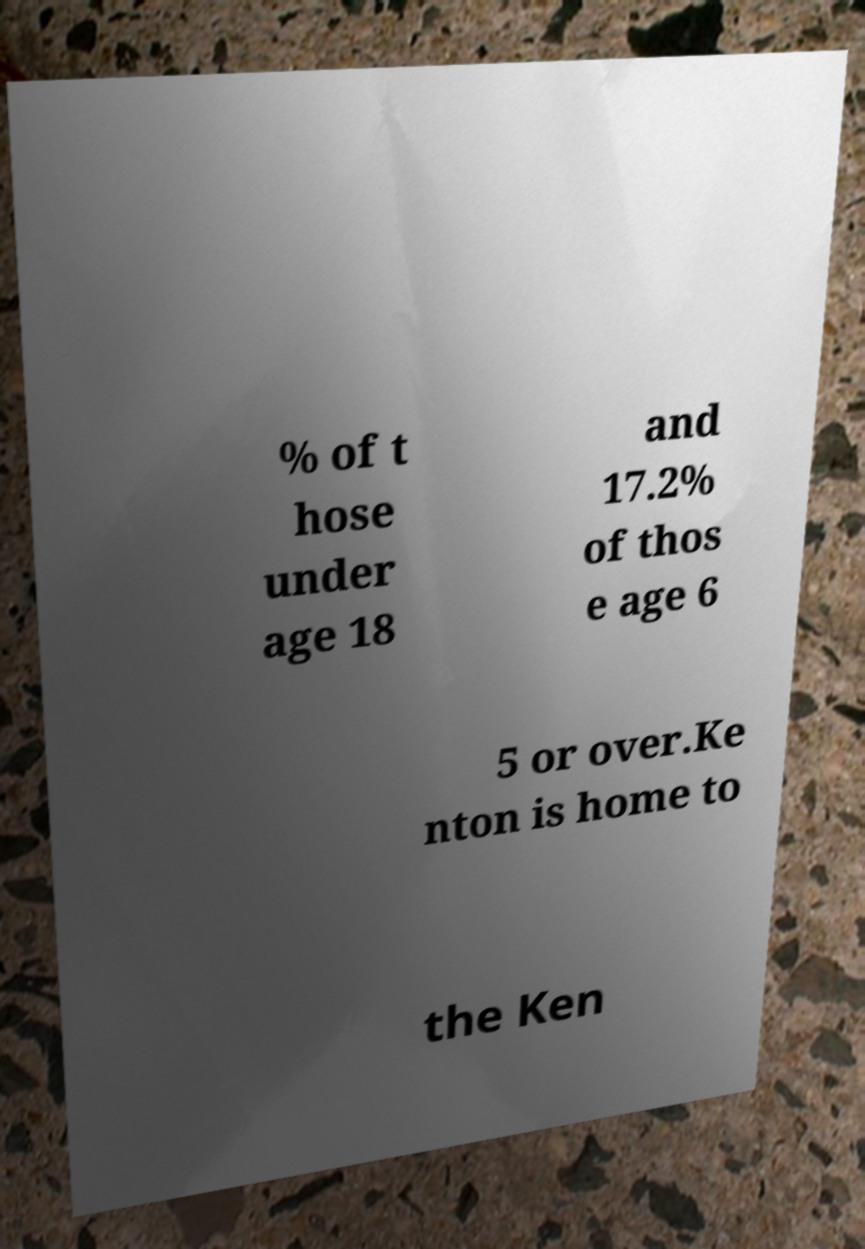Could you extract and type out the text from this image? % of t hose under age 18 and 17.2% of thos e age 6 5 or over.Ke nton is home to the Ken 